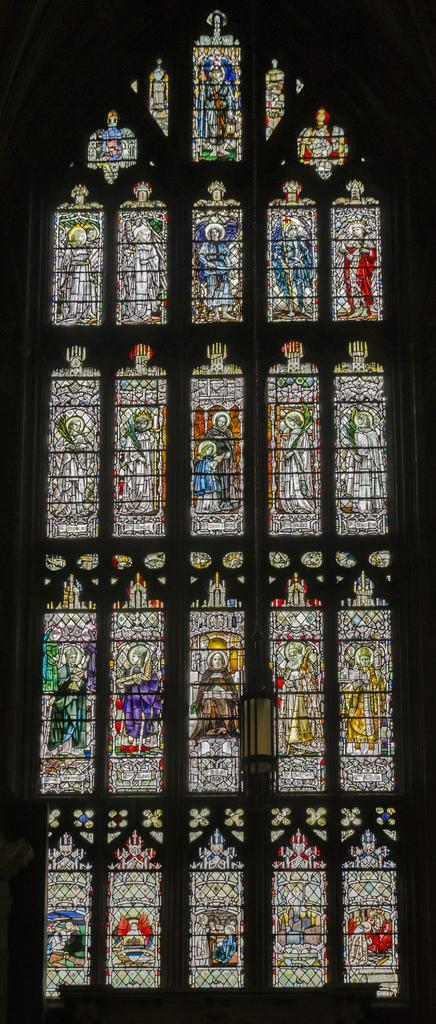What can be seen on the windows in the image? There are images on the glasses of the windows. Can you describe the images on the windows? Unfortunately, the provided facts do not give any details about the images on the windows. How many oranges are visible on the windows in the image? There is no mention of oranges in the provided facts, so we cannot determine if any are visible in the image. 